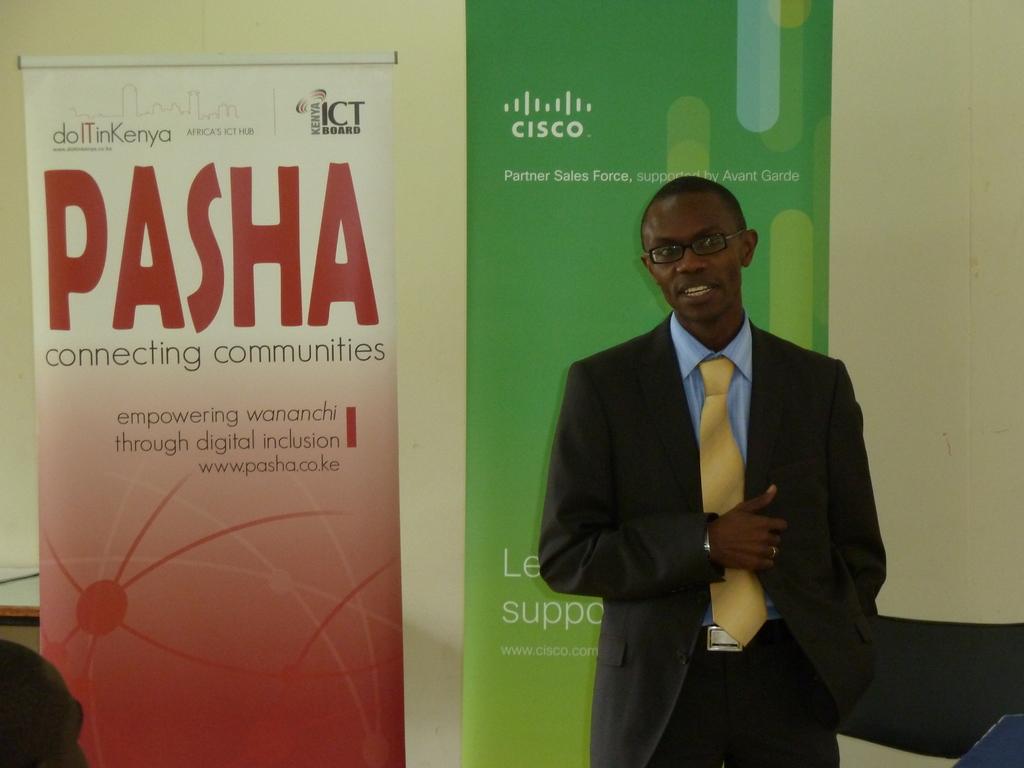Is pasha somebodies last name?
Your answer should be compact. Yes. What company is on the green sign?
Ensure brevity in your answer.  Cisco. 